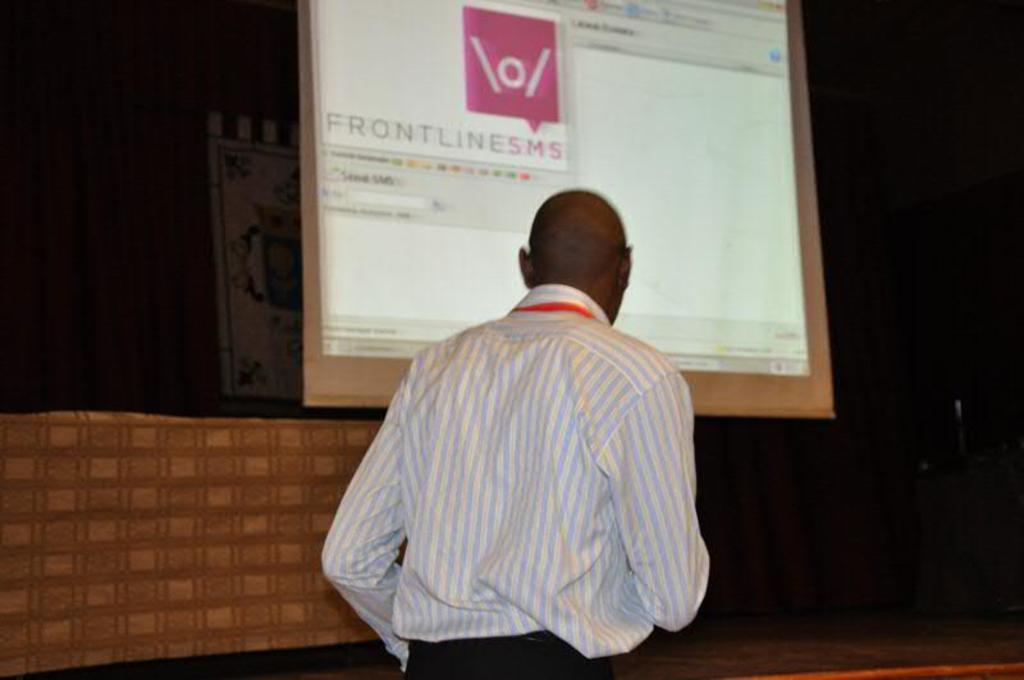What is the main subject of the image? There is a man standing in the image. Can you describe the man's appearance? The man is wearing clothes and is facing away from the camera. What can be seen on the projected screen in the image? There is text on the projected screen. How would you describe the overall lighting in the image? The background of the image is dark. What type of cannon is being used to project the text onto the screen in the image? There is no cannon present in the image; the text is projected using a different method, such as a projector. How does the man use the trick umbrella in the image? There is no umbrella present in the image, and the man is not performing any tricks. 